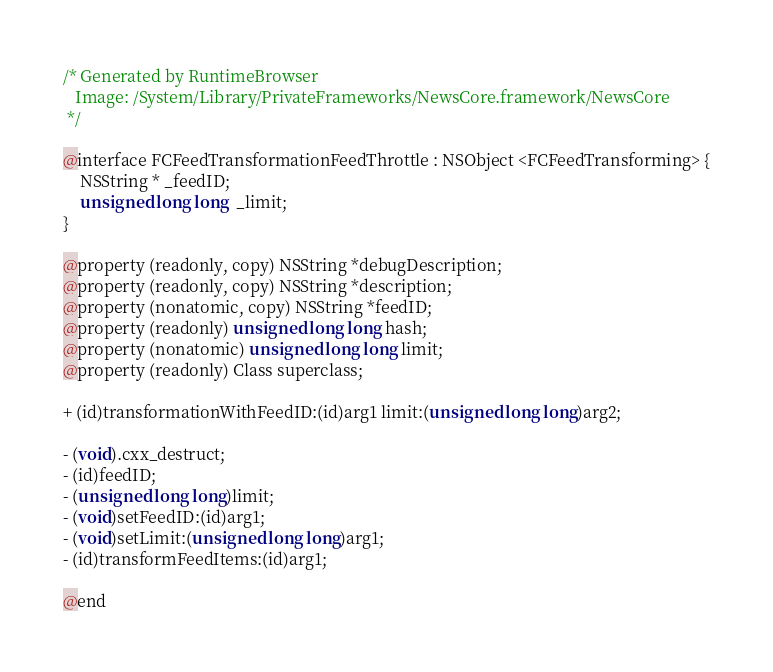<code> <loc_0><loc_0><loc_500><loc_500><_C_>/* Generated by RuntimeBrowser
   Image: /System/Library/PrivateFrameworks/NewsCore.framework/NewsCore
 */

@interface FCFeedTransformationFeedThrottle : NSObject <FCFeedTransforming> {
    NSString * _feedID;
    unsigned long long  _limit;
}

@property (readonly, copy) NSString *debugDescription;
@property (readonly, copy) NSString *description;
@property (nonatomic, copy) NSString *feedID;
@property (readonly) unsigned long long hash;
@property (nonatomic) unsigned long long limit;
@property (readonly) Class superclass;

+ (id)transformationWithFeedID:(id)arg1 limit:(unsigned long long)arg2;

- (void).cxx_destruct;
- (id)feedID;
- (unsigned long long)limit;
- (void)setFeedID:(id)arg1;
- (void)setLimit:(unsigned long long)arg1;
- (id)transformFeedItems:(id)arg1;

@end
</code> 